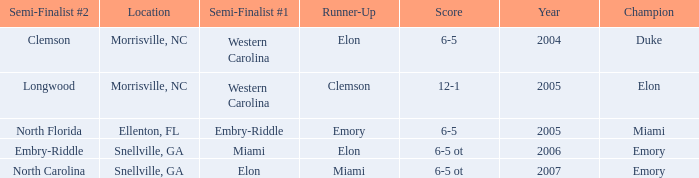Parse the full table. {'header': ['Semi-Finalist #2', 'Location', 'Semi-Finalist #1', 'Runner-Up', 'Score', 'Year', 'Champion'], 'rows': [['Clemson', 'Morrisville, NC', 'Western Carolina', 'Elon', '6-5', '2004', 'Duke'], ['Longwood', 'Morrisville, NC', 'Western Carolina', 'Clemson', '12-1', '2005', 'Elon'], ['North Florida', 'Ellenton, FL', 'Embry-Riddle', 'Emory', '6-5', '2005', 'Miami'], ['Embry-Riddle', 'Snellville, GA', 'Miami', 'Elon', '6-5 ot', '2006', 'Emory'], ['North Carolina', 'Snellville, GA', 'Elon', 'Miami', '6-5 ot', '2007', 'Emory']]} When Embry-Riddle made it to the first semi finalist slot, list all the runners up. Emory. 